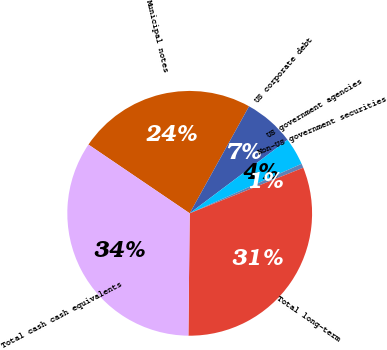<chart> <loc_0><loc_0><loc_500><loc_500><pie_chart><fcel>Municipal notes<fcel>US corporate debt<fcel>US government agencies<fcel>Non-US government securities<fcel>Total long-term<fcel>Total cash cash equivalents<nl><fcel>23.57%<fcel>6.69%<fcel>3.62%<fcel>0.55%<fcel>31.25%<fcel>34.32%<nl></chart> 